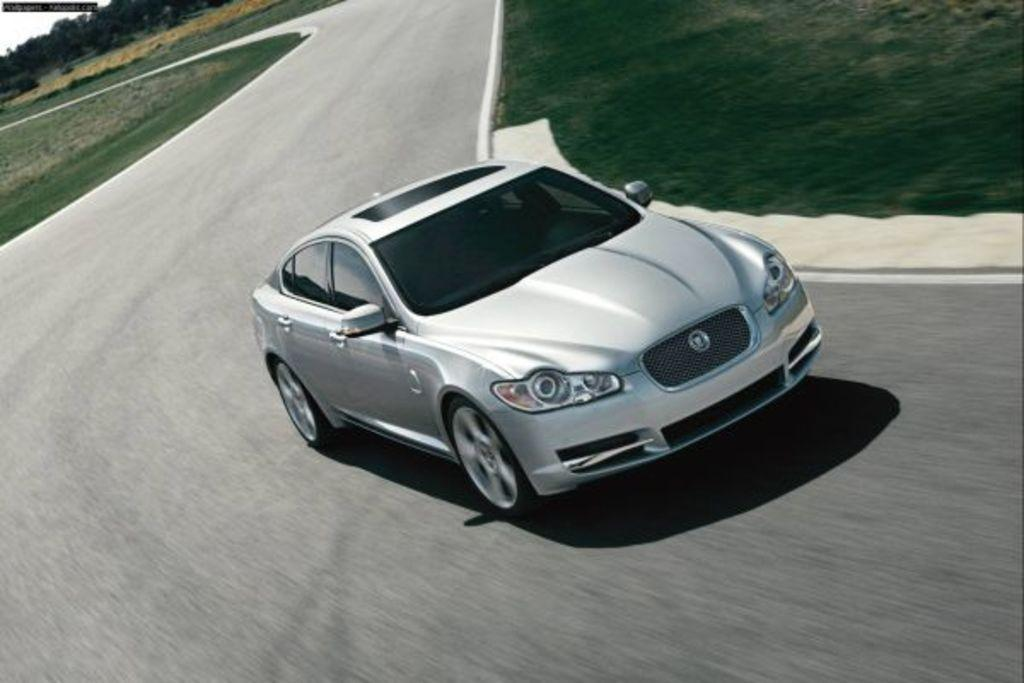What is the main subject of the image? There is a car on the road in the image. What type of vegetation can be seen in the image? Grass and trees are visible in the image. What type of game is being played on the car's roof in the image? There is no game being played on the car's roof in the image; it only shows a car on the road. What material is the iron used to make the car in the image? The image does not provide information about the materials used to make the car, nor is there any iron visible in the image. 